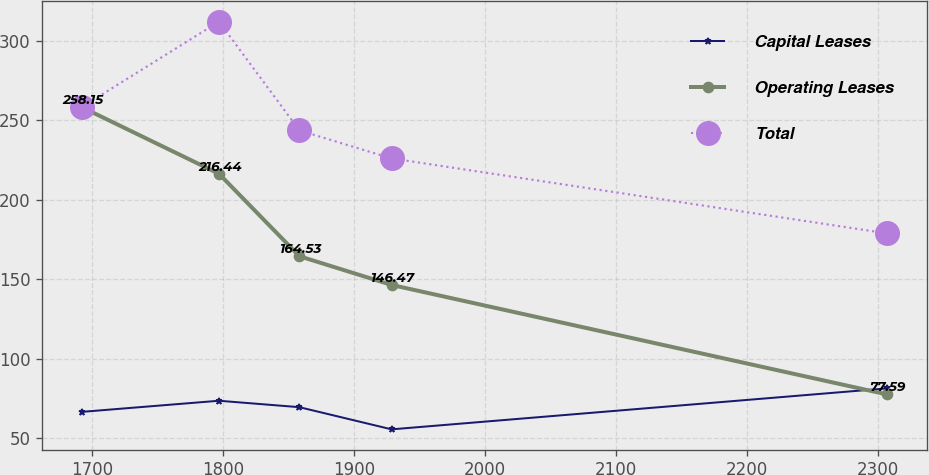<chart> <loc_0><loc_0><loc_500><loc_500><line_chart><ecel><fcel>Capital Leases<fcel>Operating Leases<fcel>Total<nl><fcel>1692.34<fcel>66.63<fcel>258.15<fcel>258.64<nl><fcel>1796.73<fcel>73.6<fcel>216.44<fcel>312.16<nl><fcel>1858.2<fcel>69.55<fcel>164.53<fcel>243.71<nl><fcel>1928.64<fcel>55.6<fcel>146.47<fcel>226.08<nl><fcel>2307.07<fcel>81.39<fcel>77.59<fcel>178.94<nl></chart> 